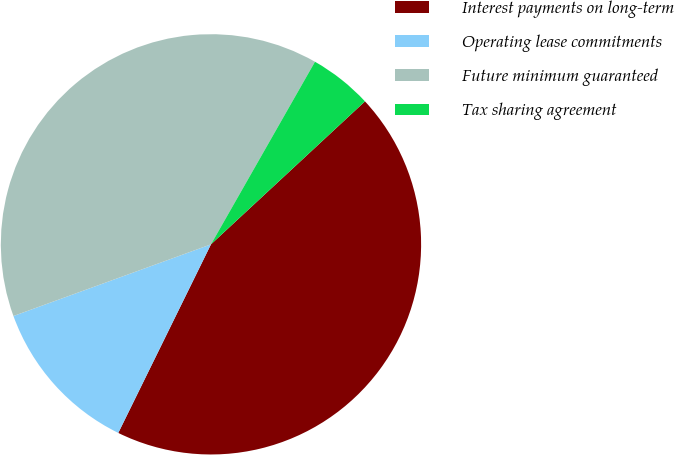Convert chart. <chart><loc_0><loc_0><loc_500><loc_500><pie_chart><fcel>Interest payments on long-term<fcel>Operating lease commitments<fcel>Future minimum guaranteed<fcel>Tax sharing agreement<nl><fcel>44.18%<fcel>12.19%<fcel>38.78%<fcel>4.85%<nl></chart> 